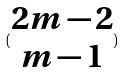<formula> <loc_0><loc_0><loc_500><loc_500>( \begin{matrix} 2 m - 2 \\ m - 1 \end{matrix} )</formula> 